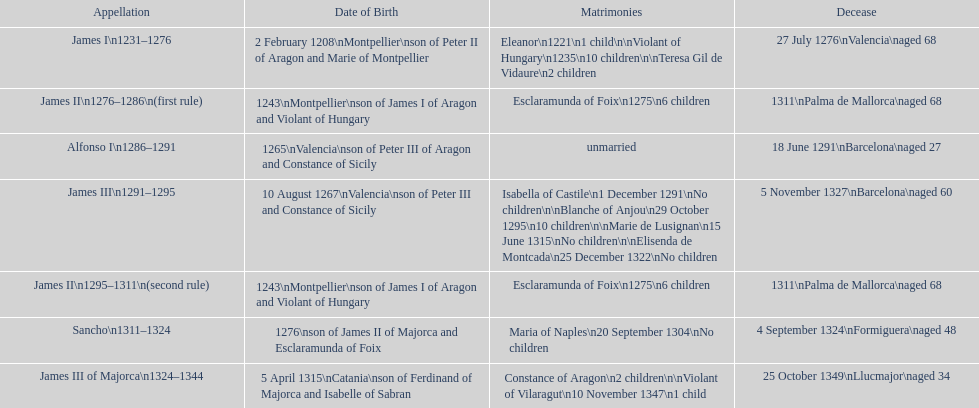Parse the full table. {'header': ['Appellation', 'Date of Birth', 'Matrimonies', 'Decease'], 'rows': [['James I\\n1231–1276', '2 February 1208\\nMontpellier\\nson of Peter II of Aragon and Marie of Montpellier', 'Eleanor\\n1221\\n1 child\\n\\nViolant of Hungary\\n1235\\n10 children\\n\\nTeresa Gil de Vidaure\\n2 children', '27 July 1276\\nValencia\\naged 68'], ['James II\\n1276–1286\\n(first rule)', '1243\\nMontpellier\\nson of James I of Aragon and Violant of Hungary', 'Esclaramunda of Foix\\n1275\\n6 children', '1311\\nPalma de Mallorca\\naged 68'], ['Alfonso I\\n1286–1291', '1265\\nValencia\\nson of Peter III of Aragon and Constance of Sicily', 'unmarried', '18 June 1291\\nBarcelona\\naged 27'], ['James III\\n1291–1295', '10 August 1267\\nValencia\\nson of Peter III and Constance of Sicily', 'Isabella of Castile\\n1 December 1291\\nNo children\\n\\nBlanche of Anjou\\n29 October 1295\\n10 children\\n\\nMarie de Lusignan\\n15 June 1315\\nNo children\\n\\nElisenda de Montcada\\n25 December 1322\\nNo children', '5 November 1327\\nBarcelona\\naged 60'], ['James II\\n1295–1311\\n(second rule)', '1243\\nMontpellier\\nson of James I of Aragon and Violant of Hungary', 'Esclaramunda of Foix\\n1275\\n6 children', '1311\\nPalma de Mallorca\\naged 68'], ['Sancho\\n1311–1324', '1276\\nson of James II of Majorca and Esclaramunda of Foix', 'Maria of Naples\\n20 September 1304\\nNo children', '4 September 1324\\nFormiguera\\naged 48'], ['James III of Majorca\\n1324–1344', '5 April 1315\\nCatania\\nson of Ferdinand of Majorca and Isabelle of Sabran', 'Constance of Aragon\\n2 children\\n\\nViolant of Vilaragut\\n10 November 1347\\n1 child', '25 October 1349\\nLlucmajor\\naged 34']]} Which monarch had the most marriages? James III 1291-1295. 